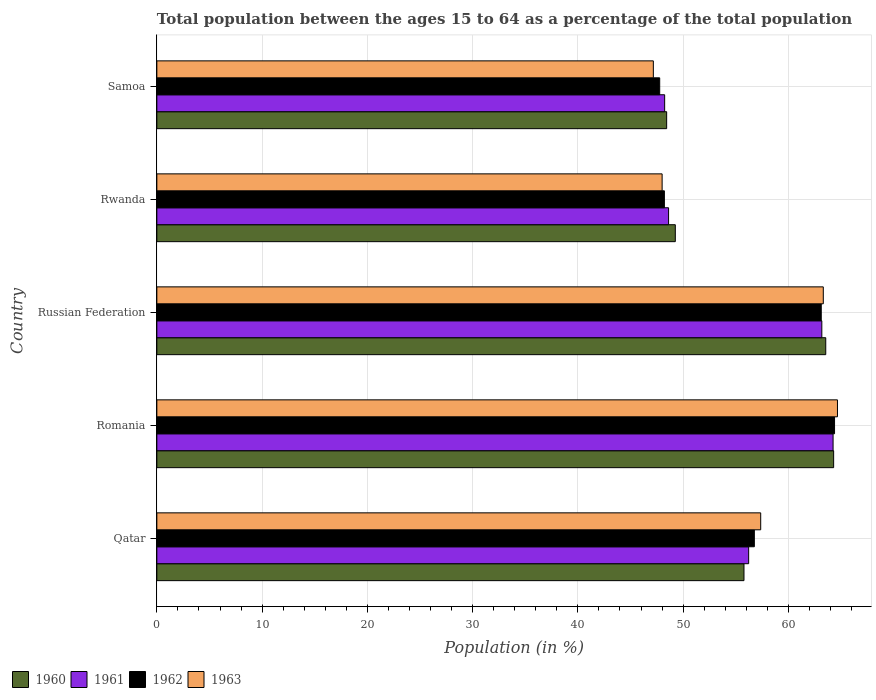How many different coloured bars are there?
Your response must be concise. 4. Are the number of bars on each tick of the Y-axis equal?
Your answer should be compact. Yes. How many bars are there on the 1st tick from the top?
Keep it short and to the point. 4. How many bars are there on the 4th tick from the bottom?
Give a very brief answer. 4. What is the label of the 5th group of bars from the top?
Provide a succinct answer. Qatar. In how many cases, is the number of bars for a given country not equal to the number of legend labels?
Ensure brevity in your answer.  0. What is the percentage of the population ages 15 to 64 in 1961 in Russian Federation?
Provide a succinct answer. 63.18. Across all countries, what is the maximum percentage of the population ages 15 to 64 in 1962?
Provide a short and direct response. 64.38. Across all countries, what is the minimum percentage of the population ages 15 to 64 in 1961?
Give a very brief answer. 48.24. In which country was the percentage of the population ages 15 to 64 in 1961 maximum?
Make the answer very short. Romania. In which country was the percentage of the population ages 15 to 64 in 1961 minimum?
Provide a succinct answer. Samoa. What is the total percentage of the population ages 15 to 64 in 1961 in the graph?
Your response must be concise. 280.5. What is the difference between the percentage of the population ages 15 to 64 in 1962 in Qatar and that in Romania?
Make the answer very short. -7.62. What is the difference between the percentage of the population ages 15 to 64 in 1961 in Romania and the percentage of the population ages 15 to 64 in 1960 in Qatar?
Your response must be concise. 8.46. What is the average percentage of the population ages 15 to 64 in 1960 per country?
Your answer should be very brief. 56.26. What is the difference between the percentage of the population ages 15 to 64 in 1960 and percentage of the population ages 15 to 64 in 1962 in Samoa?
Give a very brief answer. 0.66. What is the ratio of the percentage of the population ages 15 to 64 in 1963 in Rwanda to that in Samoa?
Your response must be concise. 1.02. Is the difference between the percentage of the population ages 15 to 64 in 1960 in Romania and Russian Federation greater than the difference between the percentage of the population ages 15 to 64 in 1962 in Romania and Russian Federation?
Provide a short and direct response. No. What is the difference between the highest and the second highest percentage of the population ages 15 to 64 in 1961?
Provide a short and direct response. 1.07. What is the difference between the highest and the lowest percentage of the population ages 15 to 64 in 1962?
Provide a short and direct response. 16.61. In how many countries, is the percentage of the population ages 15 to 64 in 1962 greater than the average percentage of the population ages 15 to 64 in 1962 taken over all countries?
Offer a very short reply. 3. Is it the case that in every country, the sum of the percentage of the population ages 15 to 64 in 1961 and percentage of the population ages 15 to 64 in 1963 is greater than the sum of percentage of the population ages 15 to 64 in 1960 and percentage of the population ages 15 to 64 in 1962?
Make the answer very short. No. What does the 2nd bar from the top in Romania represents?
Make the answer very short. 1962. Is it the case that in every country, the sum of the percentage of the population ages 15 to 64 in 1963 and percentage of the population ages 15 to 64 in 1960 is greater than the percentage of the population ages 15 to 64 in 1962?
Give a very brief answer. Yes. Are all the bars in the graph horizontal?
Give a very brief answer. Yes. How many countries are there in the graph?
Offer a very short reply. 5. Are the values on the major ticks of X-axis written in scientific E-notation?
Offer a very short reply. No. What is the title of the graph?
Offer a terse response. Total population between the ages 15 to 64 as a percentage of the total population. Does "2006" appear as one of the legend labels in the graph?
Offer a very short reply. No. What is the label or title of the X-axis?
Offer a very short reply. Population (in %). What is the Population (in %) in 1960 in Qatar?
Make the answer very short. 55.78. What is the Population (in %) in 1961 in Qatar?
Offer a very short reply. 56.22. What is the Population (in %) of 1962 in Qatar?
Offer a terse response. 56.76. What is the Population (in %) in 1963 in Qatar?
Provide a succinct answer. 57.37. What is the Population (in %) in 1960 in Romania?
Make the answer very short. 64.3. What is the Population (in %) of 1961 in Romania?
Offer a very short reply. 64.24. What is the Population (in %) in 1962 in Romania?
Provide a succinct answer. 64.38. What is the Population (in %) of 1963 in Romania?
Provide a succinct answer. 64.66. What is the Population (in %) of 1960 in Russian Federation?
Give a very brief answer. 63.55. What is the Population (in %) of 1961 in Russian Federation?
Ensure brevity in your answer.  63.18. What is the Population (in %) in 1962 in Russian Federation?
Make the answer very short. 63.12. What is the Population (in %) of 1963 in Russian Federation?
Your answer should be compact. 63.31. What is the Population (in %) of 1960 in Rwanda?
Ensure brevity in your answer.  49.26. What is the Population (in %) of 1961 in Rwanda?
Provide a short and direct response. 48.62. What is the Population (in %) in 1962 in Rwanda?
Give a very brief answer. 48.22. What is the Population (in %) of 1963 in Rwanda?
Offer a very short reply. 48. What is the Population (in %) of 1960 in Samoa?
Ensure brevity in your answer.  48.43. What is the Population (in %) in 1961 in Samoa?
Give a very brief answer. 48.24. What is the Population (in %) in 1962 in Samoa?
Provide a short and direct response. 47.77. What is the Population (in %) in 1963 in Samoa?
Keep it short and to the point. 47.17. Across all countries, what is the maximum Population (in %) in 1960?
Offer a terse response. 64.3. Across all countries, what is the maximum Population (in %) in 1961?
Provide a succinct answer. 64.24. Across all countries, what is the maximum Population (in %) in 1962?
Keep it short and to the point. 64.38. Across all countries, what is the maximum Population (in %) of 1963?
Your answer should be very brief. 64.66. Across all countries, what is the minimum Population (in %) of 1960?
Keep it short and to the point. 48.43. Across all countries, what is the minimum Population (in %) in 1961?
Your answer should be compact. 48.24. Across all countries, what is the minimum Population (in %) of 1962?
Offer a very short reply. 47.77. Across all countries, what is the minimum Population (in %) of 1963?
Provide a succinct answer. 47.17. What is the total Population (in %) of 1960 in the graph?
Your response must be concise. 281.32. What is the total Population (in %) in 1961 in the graph?
Give a very brief answer. 280.5. What is the total Population (in %) of 1962 in the graph?
Provide a succinct answer. 280.26. What is the total Population (in %) in 1963 in the graph?
Ensure brevity in your answer.  280.52. What is the difference between the Population (in %) of 1960 in Qatar and that in Romania?
Your answer should be compact. -8.52. What is the difference between the Population (in %) in 1961 in Qatar and that in Romania?
Offer a very short reply. -8.02. What is the difference between the Population (in %) of 1962 in Qatar and that in Romania?
Ensure brevity in your answer.  -7.62. What is the difference between the Population (in %) in 1963 in Qatar and that in Romania?
Make the answer very short. -7.29. What is the difference between the Population (in %) in 1960 in Qatar and that in Russian Federation?
Your answer should be very brief. -7.77. What is the difference between the Population (in %) in 1961 in Qatar and that in Russian Federation?
Provide a short and direct response. -6.95. What is the difference between the Population (in %) in 1962 in Qatar and that in Russian Federation?
Offer a very short reply. -6.36. What is the difference between the Population (in %) of 1963 in Qatar and that in Russian Federation?
Your response must be concise. -5.95. What is the difference between the Population (in %) of 1960 in Qatar and that in Rwanda?
Ensure brevity in your answer.  6.52. What is the difference between the Population (in %) of 1961 in Qatar and that in Rwanda?
Your answer should be compact. 7.61. What is the difference between the Population (in %) in 1962 in Qatar and that in Rwanda?
Ensure brevity in your answer.  8.55. What is the difference between the Population (in %) in 1963 in Qatar and that in Rwanda?
Your response must be concise. 9.37. What is the difference between the Population (in %) of 1960 in Qatar and that in Samoa?
Offer a terse response. 7.35. What is the difference between the Population (in %) of 1961 in Qatar and that in Samoa?
Offer a terse response. 7.98. What is the difference between the Population (in %) of 1962 in Qatar and that in Samoa?
Provide a succinct answer. 8.99. What is the difference between the Population (in %) in 1963 in Qatar and that in Samoa?
Your answer should be compact. 10.2. What is the difference between the Population (in %) in 1960 in Romania and that in Russian Federation?
Offer a very short reply. 0.75. What is the difference between the Population (in %) in 1961 in Romania and that in Russian Federation?
Ensure brevity in your answer.  1.07. What is the difference between the Population (in %) of 1962 in Romania and that in Russian Federation?
Provide a succinct answer. 1.26. What is the difference between the Population (in %) of 1963 in Romania and that in Russian Federation?
Ensure brevity in your answer.  1.35. What is the difference between the Population (in %) in 1960 in Romania and that in Rwanda?
Provide a succinct answer. 15.04. What is the difference between the Population (in %) of 1961 in Romania and that in Rwanda?
Offer a terse response. 15.63. What is the difference between the Population (in %) in 1962 in Romania and that in Rwanda?
Give a very brief answer. 16.17. What is the difference between the Population (in %) of 1963 in Romania and that in Rwanda?
Provide a succinct answer. 16.66. What is the difference between the Population (in %) in 1960 in Romania and that in Samoa?
Your response must be concise. 15.86. What is the difference between the Population (in %) of 1961 in Romania and that in Samoa?
Provide a succinct answer. 16. What is the difference between the Population (in %) in 1962 in Romania and that in Samoa?
Your response must be concise. 16.61. What is the difference between the Population (in %) in 1963 in Romania and that in Samoa?
Your answer should be compact. 17.49. What is the difference between the Population (in %) of 1960 in Russian Federation and that in Rwanda?
Your response must be concise. 14.29. What is the difference between the Population (in %) of 1961 in Russian Federation and that in Rwanda?
Keep it short and to the point. 14.56. What is the difference between the Population (in %) of 1962 in Russian Federation and that in Rwanda?
Your answer should be compact. 14.9. What is the difference between the Population (in %) in 1963 in Russian Federation and that in Rwanda?
Your answer should be compact. 15.31. What is the difference between the Population (in %) of 1960 in Russian Federation and that in Samoa?
Make the answer very short. 15.11. What is the difference between the Population (in %) in 1961 in Russian Federation and that in Samoa?
Your response must be concise. 14.93. What is the difference between the Population (in %) in 1962 in Russian Federation and that in Samoa?
Your answer should be very brief. 15.35. What is the difference between the Population (in %) in 1963 in Russian Federation and that in Samoa?
Provide a succinct answer. 16.15. What is the difference between the Population (in %) of 1960 in Rwanda and that in Samoa?
Provide a succinct answer. 0.82. What is the difference between the Population (in %) in 1961 in Rwanda and that in Samoa?
Give a very brief answer. 0.37. What is the difference between the Population (in %) of 1962 in Rwanda and that in Samoa?
Your answer should be compact. 0.44. What is the difference between the Population (in %) in 1963 in Rwanda and that in Samoa?
Provide a short and direct response. 0.83. What is the difference between the Population (in %) of 1960 in Qatar and the Population (in %) of 1961 in Romania?
Ensure brevity in your answer.  -8.46. What is the difference between the Population (in %) of 1960 in Qatar and the Population (in %) of 1962 in Romania?
Give a very brief answer. -8.6. What is the difference between the Population (in %) in 1960 in Qatar and the Population (in %) in 1963 in Romania?
Keep it short and to the point. -8.88. What is the difference between the Population (in %) of 1961 in Qatar and the Population (in %) of 1962 in Romania?
Make the answer very short. -8.16. What is the difference between the Population (in %) in 1961 in Qatar and the Population (in %) in 1963 in Romania?
Your answer should be very brief. -8.44. What is the difference between the Population (in %) in 1962 in Qatar and the Population (in %) in 1963 in Romania?
Make the answer very short. -7.9. What is the difference between the Population (in %) in 1960 in Qatar and the Population (in %) in 1961 in Russian Federation?
Make the answer very short. -7.4. What is the difference between the Population (in %) in 1960 in Qatar and the Population (in %) in 1962 in Russian Federation?
Make the answer very short. -7.34. What is the difference between the Population (in %) of 1960 in Qatar and the Population (in %) of 1963 in Russian Federation?
Give a very brief answer. -7.53. What is the difference between the Population (in %) in 1961 in Qatar and the Population (in %) in 1962 in Russian Federation?
Make the answer very short. -6.9. What is the difference between the Population (in %) in 1961 in Qatar and the Population (in %) in 1963 in Russian Federation?
Offer a very short reply. -7.09. What is the difference between the Population (in %) of 1962 in Qatar and the Population (in %) of 1963 in Russian Federation?
Offer a very short reply. -6.55. What is the difference between the Population (in %) in 1960 in Qatar and the Population (in %) in 1961 in Rwanda?
Provide a succinct answer. 7.16. What is the difference between the Population (in %) in 1960 in Qatar and the Population (in %) in 1962 in Rwanda?
Your answer should be compact. 7.56. What is the difference between the Population (in %) in 1960 in Qatar and the Population (in %) in 1963 in Rwanda?
Provide a short and direct response. 7.78. What is the difference between the Population (in %) in 1961 in Qatar and the Population (in %) in 1962 in Rwanda?
Your answer should be compact. 8.01. What is the difference between the Population (in %) of 1961 in Qatar and the Population (in %) of 1963 in Rwanda?
Offer a very short reply. 8.22. What is the difference between the Population (in %) in 1962 in Qatar and the Population (in %) in 1963 in Rwanda?
Make the answer very short. 8.76. What is the difference between the Population (in %) of 1960 in Qatar and the Population (in %) of 1961 in Samoa?
Your answer should be very brief. 7.54. What is the difference between the Population (in %) in 1960 in Qatar and the Population (in %) in 1962 in Samoa?
Ensure brevity in your answer.  8.01. What is the difference between the Population (in %) of 1960 in Qatar and the Population (in %) of 1963 in Samoa?
Offer a very short reply. 8.61. What is the difference between the Population (in %) of 1961 in Qatar and the Population (in %) of 1962 in Samoa?
Give a very brief answer. 8.45. What is the difference between the Population (in %) in 1961 in Qatar and the Population (in %) in 1963 in Samoa?
Provide a succinct answer. 9.06. What is the difference between the Population (in %) of 1962 in Qatar and the Population (in %) of 1963 in Samoa?
Your answer should be compact. 9.6. What is the difference between the Population (in %) of 1960 in Romania and the Population (in %) of 1961 in Russian Federation?
Offer a terse response. 1.12. What is the difference between the Population (in %) in 1960 in Romania and the Population (in %) in 1962 in Russian Federation?
Provide a succinct answer. 1.18. What is the difference between the Population (in %) in 1960 in Romania and the Population (in %) in 1963 in Russian Federation?
Your answer should be compact. 0.98. What is the difference between the Population (in %) in 1961 in Romania and the Population (in %) in 1962 in Russian Federation?
Provide a succinct answer. 1.12. What is the difference between the Population (in %) in 1961 in Romania and the Population (in %) in 1963 in Russian Federation?
Provide a short and direct response. 0.93. What is the difference between the Population (in %) of 1962 in Romania and the Population (in %) of 1963 in Russian Federation?
Your answer should be compact. 1.07. What is the difference between the Population (in %) of 1960 in Romania and the Population (in %) of 1961 in Rwanda?
Ensure brevity in your answer.  15.68. What is the difference between the Population (in %) of 1960 in Romania and the Population (in %) of 1962 in Rwanda?
Make the answer very short. 16.08. What is the difference between the Population (in %) of 1960 in Romania and the Population (in %) of 1963 in Rwanda?
Provide a succinct answer. 16.29. What is the difference between the Population (in %) of 1961 in Romania and the Population (in %) of 1962 in Rwanda?
Offer a very short reply. 16.03. What is the difference between the Population (in %) in 1961 in Romania and the Population (in %) in 1963 in Rwanda?
Provide a succinct answer. 16.24. What is the difference between the Population (in %) in 1962 in Romania and the Population (in %) in 1963 in Rwanda?
Give a very brief answer. 16.38. What is the difference between the Population (in %) of 1960 in Romania and the Population (in %) of 1961 in Samoa?
Ensure brevity in your answer.  16.05. What is the difference between the Population (in %) of 1960 in Romania and the Population (in %) of 1962 in Samoa?
Keep it short and to the point. 16.52. What is the difference between the Population (in %) of 1960 in Romania and the Population (in %) of 1963 in Samoa?
Ensure brevity in your answer.  17.13. What is the difference between the Population (in %) in 1961 in Romania and the Population (in %) in 1962 in Samoa?
Provide a succinct answer. 16.47. What is the difference between the Population (in %) in 1961 in Romania and the Population (in %) in 1963 in Samoa?
Your answer should be very brief. 17.07. What is the difference between the Population (in %) in 1962 in Romania and the Population (in %) in 1963 in Samoa?
Ensure brevity in your answer.  17.21. What is the difference between the Population (in %) in 1960 in Russian Federation and the Population (in %) in 1961 in Rwanda?
Keep it short and to the point. 14.93. What is the difference between the Population (in %) in 1960 in Russian Federation and the Population (in %) in 1962 in Rwanda?
Make the answer very short. 15.33. What is the difference between the Population (in %) in 1960 in Russian Federation and the Population (in %) in 1963 in Rwanda?
Give a very brief answer. 15.55. What is the difference between the Population (in %) in 1961 in Russian Federation and the Population (in %) in 1962 in Rwanda?
Provide a short and direct response. 14.96. What is the difference between the Population (in %) in 1961 in Russian Federation and the Population (in %) in 1963 in Rwanda?
Keep it short and to the point. 15.17. What is the difference between the Population (in %) in 1962 in Russian Federation and the Population (in %) in 1963 in Rwanda?
Provide a succinct answer. 15.12. What is the difference between the Population (in %) in 1960 in Russian Federation and the Population (in %) in 1961 in Samoa?
Your response must be concise. 15.31. What is the difference between the Population (in %) in 1960 in Russian Federation and the Population (in %) in 1962 in Samoa?
Provide a succinct answer. 15.78. What is the difference between the Population (in %) of 1960 in Russian Federation and the Population (in %) of 1963 in Samoa?
Offer a terse response. 16.38. What is the difference between the Population (in %) in 1961 in Russian Federation and the Population (in %) in 1962 in Samoa?
Your answer should be very brief. 15.4. What is the difference between the Population (in %) in 1961 in Russian Federation and the Population (in %) in 1963 in Samoa?
Provide a short and direct response. 16.01. What is the difference between the Population (in %) of 1962 in Russian Federation and the Population (in %) of 1963 in Samoa?
Make the answer very short. 15.95. What is the difference between the Population (in %) of 1960 in Rwanda and the Population (in %) of 1961 in Samoa?
Give a very brief answer. 1.01. What is the difference between the Population (in %) in 1960 in Rwanda and the Population (in %) in 1962 in Samoa?
Make the answer very short. 1.48. What is the difference between the Population (in %) in 1960 in Rwanda and the Population (in %) in 1963 in Samoa?
Your answer should be very brief. 2.09. What is the difference between the Population (in %) in 1961 in Rwanda and the Population (in %) in 1962 in Samoa?
Keep it short and to the point. 0.84. What is the difference between the Population (in %) in 1961 in Rwanda and the Population (in %) in 1963 in Samoa?
Your answer should be very brief. 1.45. What is the difference between the Population (in %) in 1962 in Rwanda and the Population (in %) in 1963 in Samoa?
Make the answer very short. 1.05. What is the average Population (in %) of 1960 per country?
Your answer should be very brief. 56.26. What is the average Population (in %) in 1961 per country?
Give a very brief answer. 56.1. What is the average Population (in %) in 1962 per country?
Keep it short and to the point. 56.05. What is the average Population (in %) in 1963 per country?
Provide a succinct answer. 56.1. What is the difference between the Population (in %) of 1960 and Population (in %) of 1961 in Qatar?
Offer a very short reply. -0.44. What is the difference between the Population (in %) in 1960 and Population (in %) in 1962 in Qatar?
Keep it short and to the point. -0.98. What is the difference between the Population (in %) of 1960 and Population (in %) of 1963 in Qatar?
Provide a succinct answer. -1.59. What is the difference between the Population (in %) of 1961 and Population (in %) of 1962 in Qatar?
Provide a short and direct response. -0.54. What is the difference between the Population (in %) of 1961 and Population (in %) of 1963 in Qatar?
Provide a succinct answer. -1.14. What is the difference between the Population (in %) of 1962 and Population (in %) of 1963 in Qatar?
Your answer should be compact. -0.6. What is the difference between the Population (in %) of 1960 and Population (in %) of 1961 in Romania?
Provide a succinct answer. 0.05. What is the difference between the Population (in %) of 1960 and Population (in %) of 1962 in Romania?
Ensure brevity in your answer.  -0.09. What is the difference between the Population (in %) in 1960 and Population (in %) in 1963 in Romania?
Give a very brief answer. -0.36. What is the difference between the Population (in %) in 1961 and Population (in %) in 1962 in Romania?
Your response must be concise. -0.14. What is the difference between the Population (in %) in 1961 and Population (in %) in 1963 in Romania?
Keep it short and to the point. -0.42. What is the difference between the Population (in %) in 1962 and Population (in %) in 1963 in Romania?
Make the answer very short. -0.28. What is the difference between the Population (in %) in 1960 and Population (in %) in 1961 in Russian Federation?
Offer a terse response. 0.37. What is the difference between the Population (in %) in 1960 and Population (in %) in 1962 in Russian Federation?
Provide a short and direct response. 0.43. What is the difference between the Population (in %) of 1960 and Population (in %) of 1963 in Russian Federation?
Offer a very short reply. 0.23. What is the difference between the Population (in %) in 1961 and Population (in %) in 1962 in Russian Federation?
Provide a succinct answer. 0.06. What is the difference between the Population (in %) of 1961 and Population (in %) of 1963 in Russian Federation?
Your answer should be compact. -0.14. What is the difference between the Population (in %) of 1962 and Population (in %) of 1963 in Russian Federation?
Offer a very short reply. -0.19. What is the difference between the Population (in %) of 1960 and Population (in %) of 1961 in Rwanda?
Provide a short and direct response. 0.64. What is the difference between the Population (in %) in 1960 and Population (in %) in 1962 in Rwanda?
Provide a succinct answer. 1.04. What is the difference between the Population (in %) of 1960 and Population (in %) of 1963 in Rwanda?
Ensure brevity in your answer.  1.25. What is the difference between the Population (in %) of 1961 and Population (in %) of 1962 in Rwanda?
Provide a short and direct response. 0.4. What is the difference between the Population (in %) in 1961 and Population (in %) in 1963 in Rwanda?
Make the answer very short. 0.61. What is the difference between the Population (in %) of 1962 and Population (in %) of 1963 in Rwanda?
Keep it short and to the point. 0.21. What is the difference between the Population (in %) in 1960 and Population (in %) in 1961 in Samoa?
Give a very brief answer. 0.19. What is the difference between the Population (in %) of 1960 and Population (in %) of 1962 in Samoa?
Your answer should be very brief. 0.66. What is the difference between the Population (in %) of 1960 and Population (in %) of 1963 in Samoa?
Offer a very short reply. 1.26. What is the difference between the Population (in %) of 1961 and Population (in %) of 1962 in Samoa?
Keep it short and to the point. 0.47. What is the difference between the Population (in %) in 1961 and Population (in %) in 1963 in Samoa?
Provide a short and direct response. 1.07. What is the difference between the Population (in %) of 1962 and Population (in %) of 1963 in Samoa?
Your answer should be compact. 0.6. What is the ratio of the Population (in %) of 1960 in Qatar to that in Romania?
Make the answer very short. 0.87. What is the ratio of the Population (in %) in 1961 in Qatar to that in Romania?
Keep it short and to the point. 0.88. What is the ratio of the Population (in %) in 1962 in Qatar to that in Romania?
Ensure brevity in your answer.  0.88. What is the ratio of the Population (in %) of 1963 in Qatar to that in Romania?
Your answer should be compact. 0.89. What is the ratio of the Population (in %) of 1960 in Qatar to that in Russian Federation?
Your answer should be compact. 0.88. What is the ratio of the Population (in %) of 1961 in Qatar to that in Russian Federation?
Offer a very short reply. 0.89. What is the ratio of the Population (in %) in 1962 in Qatar to that in Russian Federation?
Offer a terse response. 0.9. What is the ratio of the Population (in %) of 1963 in Qatar to that in Russian Federation?
Your response must be concise. 0.91. What is the ratio of the Population (in %) of 1960 in Qatar to that in Rwanda?
Make the answer very short. 1.13. What is the ratio of the Population (in %) in 1961 in Qatar to that in Rwanda?
Your answer should be very brief. 1.16. What is the ratio of the Population (in %) of 1962 in Qatar to that in Rwanda?
Provide a succinct answer. 1.18. What is the ratio of the Population (in %) in 1963 in Qatar to that in Rwanda?
Keep it short and to the point. 1.2. What is the ratio of the Population (in %) of 1960 in Qatar to that in Samoa?
Make the answer very short. 1.15. What is the ratio of the Population (in %) in 1961 in Qatar to that in Samoa?
Provide a succinct answer. 1.17. What is the ratio of the Population (in %) in 1962 in Qatar to that in Samoa?
Make the answer very short. 1.19. What is the ratio of the Population (in %) of 1963 in Qatar to that in Samoa?
Provide a short and direct response. 1.22. What is the ratio of the Population (in %) in 1960 in Romania to that in Russian Federation?
Offer a terse response. 1.01. What is the ratio of the Population (in %) of 1961 in Romania to that in Russian Federation?
Your answer should be very brief. 1.02. What is the ratio of the Population (in %) in 1963 in Romania to that in Russian Federation?
Offer a very short reply. 1.02. What is the ratio of the Population (in %) of 1960 in Romania to that in Rwanda?
Your answer should be compact. 1.31. What is the ratio of the Population (in %) of 1961 in Romania to that in Rwanda?
Give a very brief answer. 1.32. What is the ratio of the Population (in %) of 1962 in Romania to that in Rwanda?
Provide a short and direct response. 1.34. What is the ratio of the Population (in %) of 1963 in Romania to that in Rwanda?
Offer a very short reply. 1.35. What is the ratio of the Population (in %) in 1960 in Romania to that in Samoa?
Ensure brevity in your answer.  1.33. What is the ratio of the Population (in %) in 1961 in Romania to that in Samoa?
Give a very brief answer. 1.33. What is the ratio of the Population (in %) of 1962 in Romania to that in Samoa?
Offer a very short reply. 1.35. What is the ratio of the Population (in %) of 1963 in Romania to that in Samoa?
Provide a short and direct response. 1.37. What is the ratio of the Population (in %) of 1960 in Russian Federation to that in Rwanda?
Your response must be concise. 1.29. What is the ratio of the Population (in %) in 1961 in Russian Federation to that in Rwanda?
Give a very brief answer. 1.3. What is the ratio of the Population (in %) in 1962 in Russian Federation to that in Rwanda?
Your answer should be very brief. 1.31. What is the ratio of the Population (in %) of 1963 in Russian Federation to that in Rwanda?
Keep it short and to the point. 1.32. What is the ratio of the Population (in %) in 1960 in Russian Federation to that in Samoa?
Keep it short and to the point. 1.31. What is the ratio of the Population (in %) in 1961 in Russian Federation to that in Samoa?
Give a very brief answer. 1.31. What is the ratio of the Population (in %) in 1962 in Russian Federation to that in Samoa?
Keep it short and to the point. 1.32. What is the ratio of the Population (in %) of 1963 in Russian Federation to that in Samoa?
Keep it short and to the point. 1.34. What is the ratio of the Population (in %) of 1961 in Rwanda to that in Samoa?
Your response must be concise. 1.01. What is the ratio of the Population (in %) in 1962 in Rwanda to that in Samoa?
Your response must be concise. 1.01. What is the ratio of the Population (in %) in 1963 in Rwanda to that in Samoa?
Keep it short and to the point. 1.02. What is the difference between the highest and the second highest Population (in %) in 1960?
Offer a terse response. 0.75. What is the difference between the highest and the second highest Population (in %) in 1961?
Make the answer very short. 1.07. What is the difference between the highest and the second highest Population (in %) of 1962?
Ensure brevity in your answer.  1.26. What is the difference between the highest and the second highest Population (in %) of 1963?
Offer a very short reply. 1.35. What is the difference between the highest and the lowest Population (in %) in 1960?
Offer a terse response. 15.86. What is the difference between the highest and the lowest Population (in %) in 1961?
Offer a terse response. 16. What is the difference between the highest and the lowest Population (in %) of 1962?
Your response must be concise. 16.61. What is the difference between the highest and the lowest Population (in %) in 1963?
Your response must be concise. 17.49. 